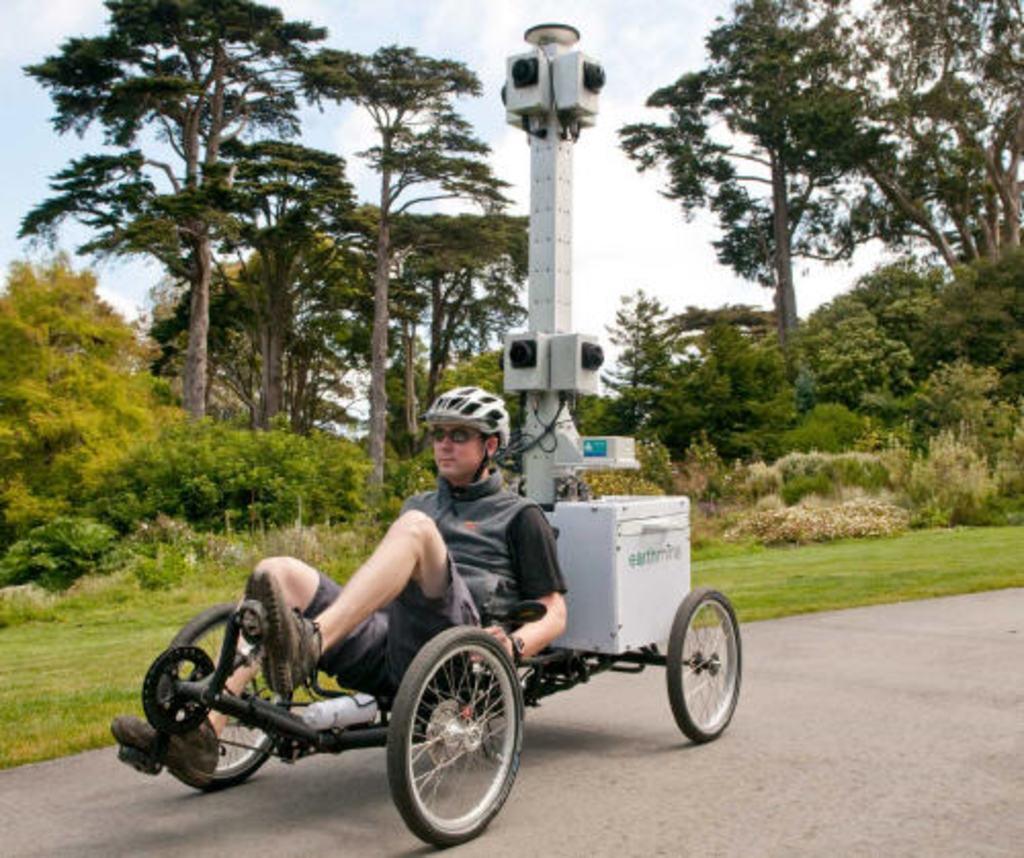Please provide a concise description of this image. In the center of the image there is a person riding a cart. In the background of the image there are trees. There is grass. At the bottom of the image there is road. 